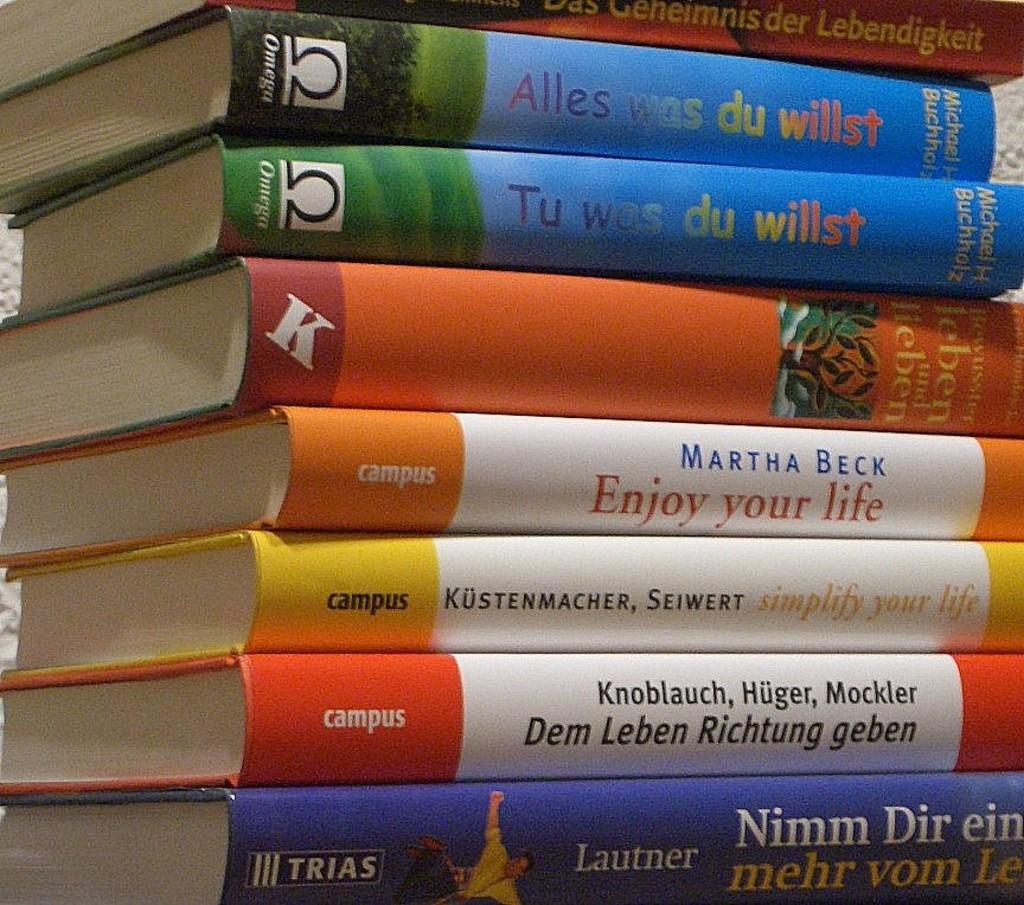What is the title of the book by seiwer kustenmacher?
Make the answer very short. Simplify your life. 